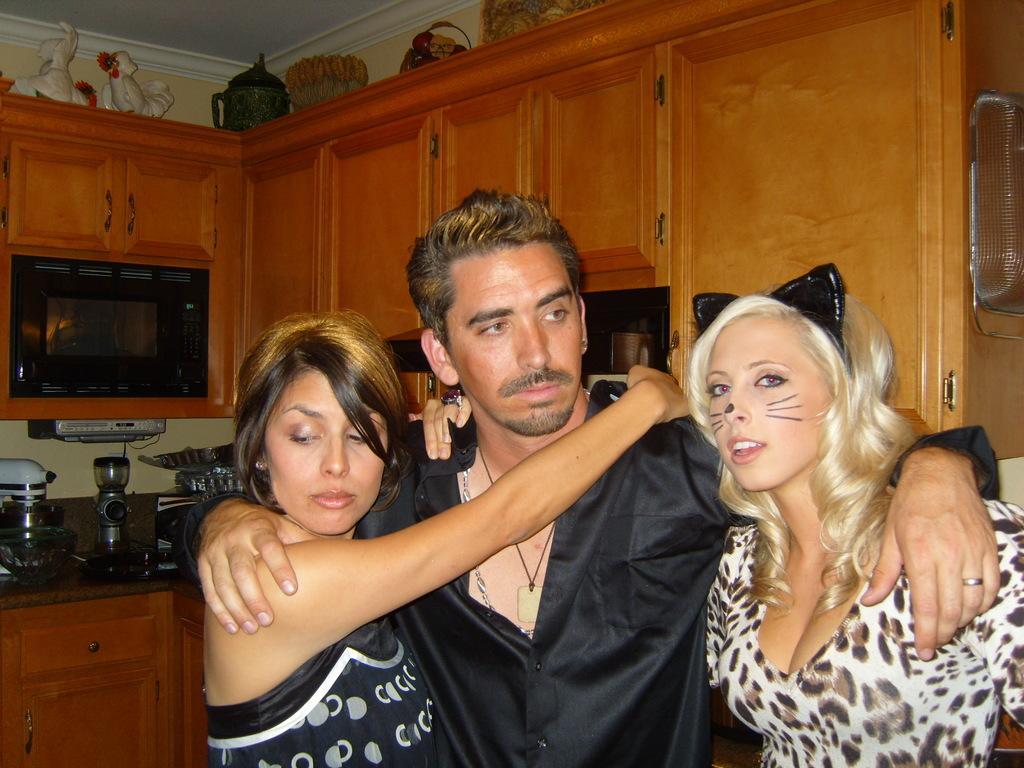Can you describe this image briefly? In the picture I can see a man in the middle of the image and he is wearing a black color shirt. I can see a woman on the left side and there is another woman on the right side. In the background, I can see the wooden drawers. I can see a glass bowl on the marble table on the left side. 